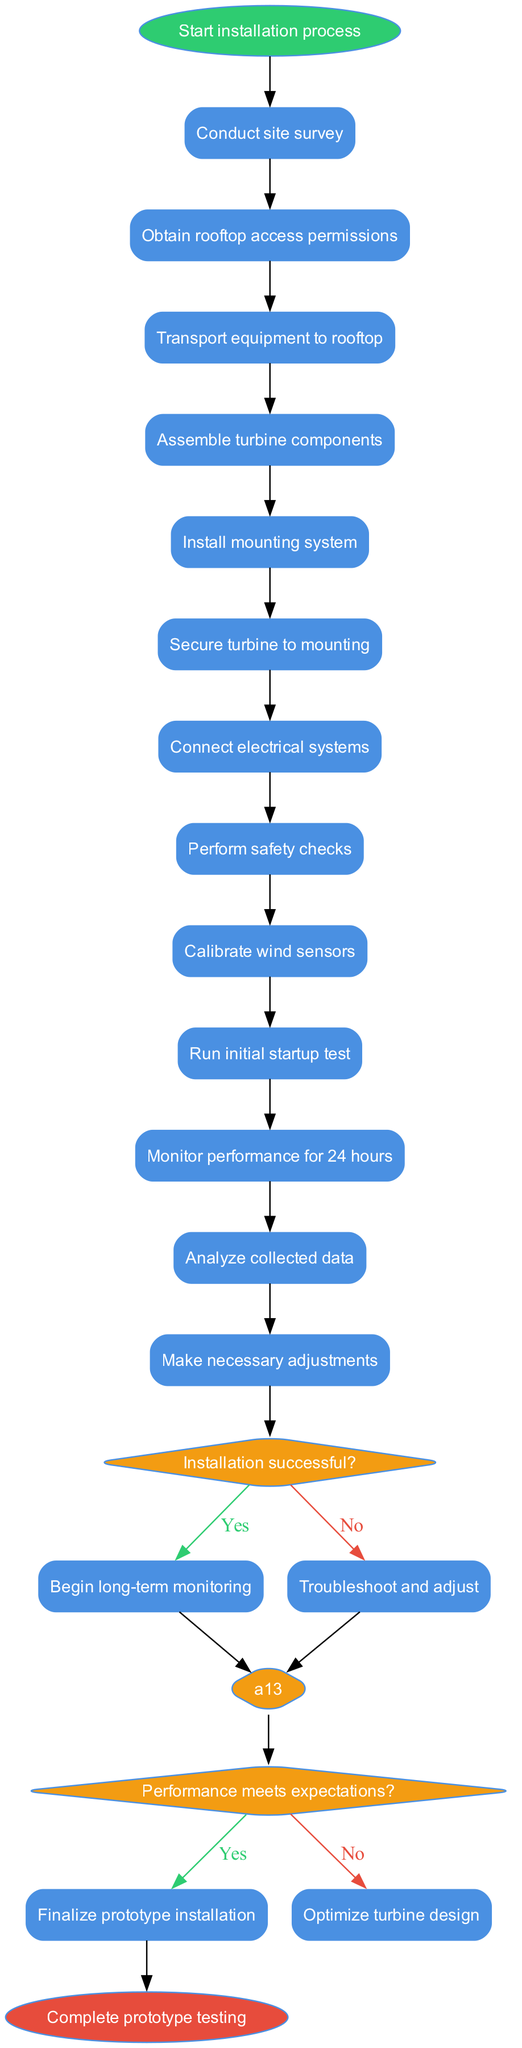What is the initial step in the installation process? The diagram begins with the node labeled "Start installation process," which indicates the first step of the workflow.
Answer: Start installation process How many activities are involved in this workflow? The diagram lists a total of 13 activities that are part of the installation and testing process, starting from the site survey to making adjustments.
Answer: 13 What decision follows the safety checks? After performing the safety checks, the next decision node asks the question "Installation successful?", which determines the subsequent steps based on the outcome.
Answer: Installation successful? What happens if the installation is not successful? If the answer to the question "Installation successful?" is no, the workflow indicates that the next step is "Troubleshoot and adjust," which is meant to resolve any issues preventing successful installation.
Answer: Troubleshoot and adjust How many decision nodes are present in the diagram? The diagram contains 2 decision nodes, each evaluating different aspects of the installation process.
Answer: 2 What is the final step of the workflow? The last step of the workflow, after successfully completing the prototype testing, is denoted by the node "Complete prototype testing," which signifies the conclusion of the process.
Answer: Complete prototype testing If the performance meets expectations, what is the next step? If the answer to the question "Performance meets expectations?" is yes, the workflow directs to "Finalize prototype installation," indicating a successful completion of that part of the process.
Answer: Finalize prototype installation What should be done if performance does not meet expectations? The workflow indicates that if the performance does not meet expectations, the next step is to "Optimize turbine design," which suggests making design improvements based on performance data.
Answer: Optimize turbine design Which activity comes after transporting equipment to the rooftop? Following the transportation of equipment to the rooftop, the next activity is "Assemble turbine components," indicating the next actionable task in the workflow.
Answer: Assemble turbine components 